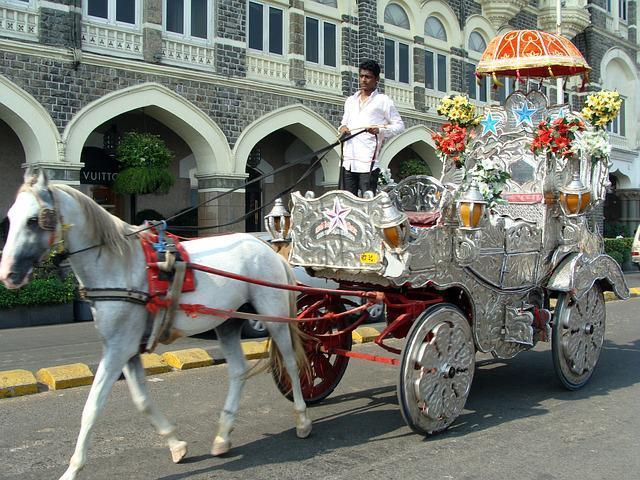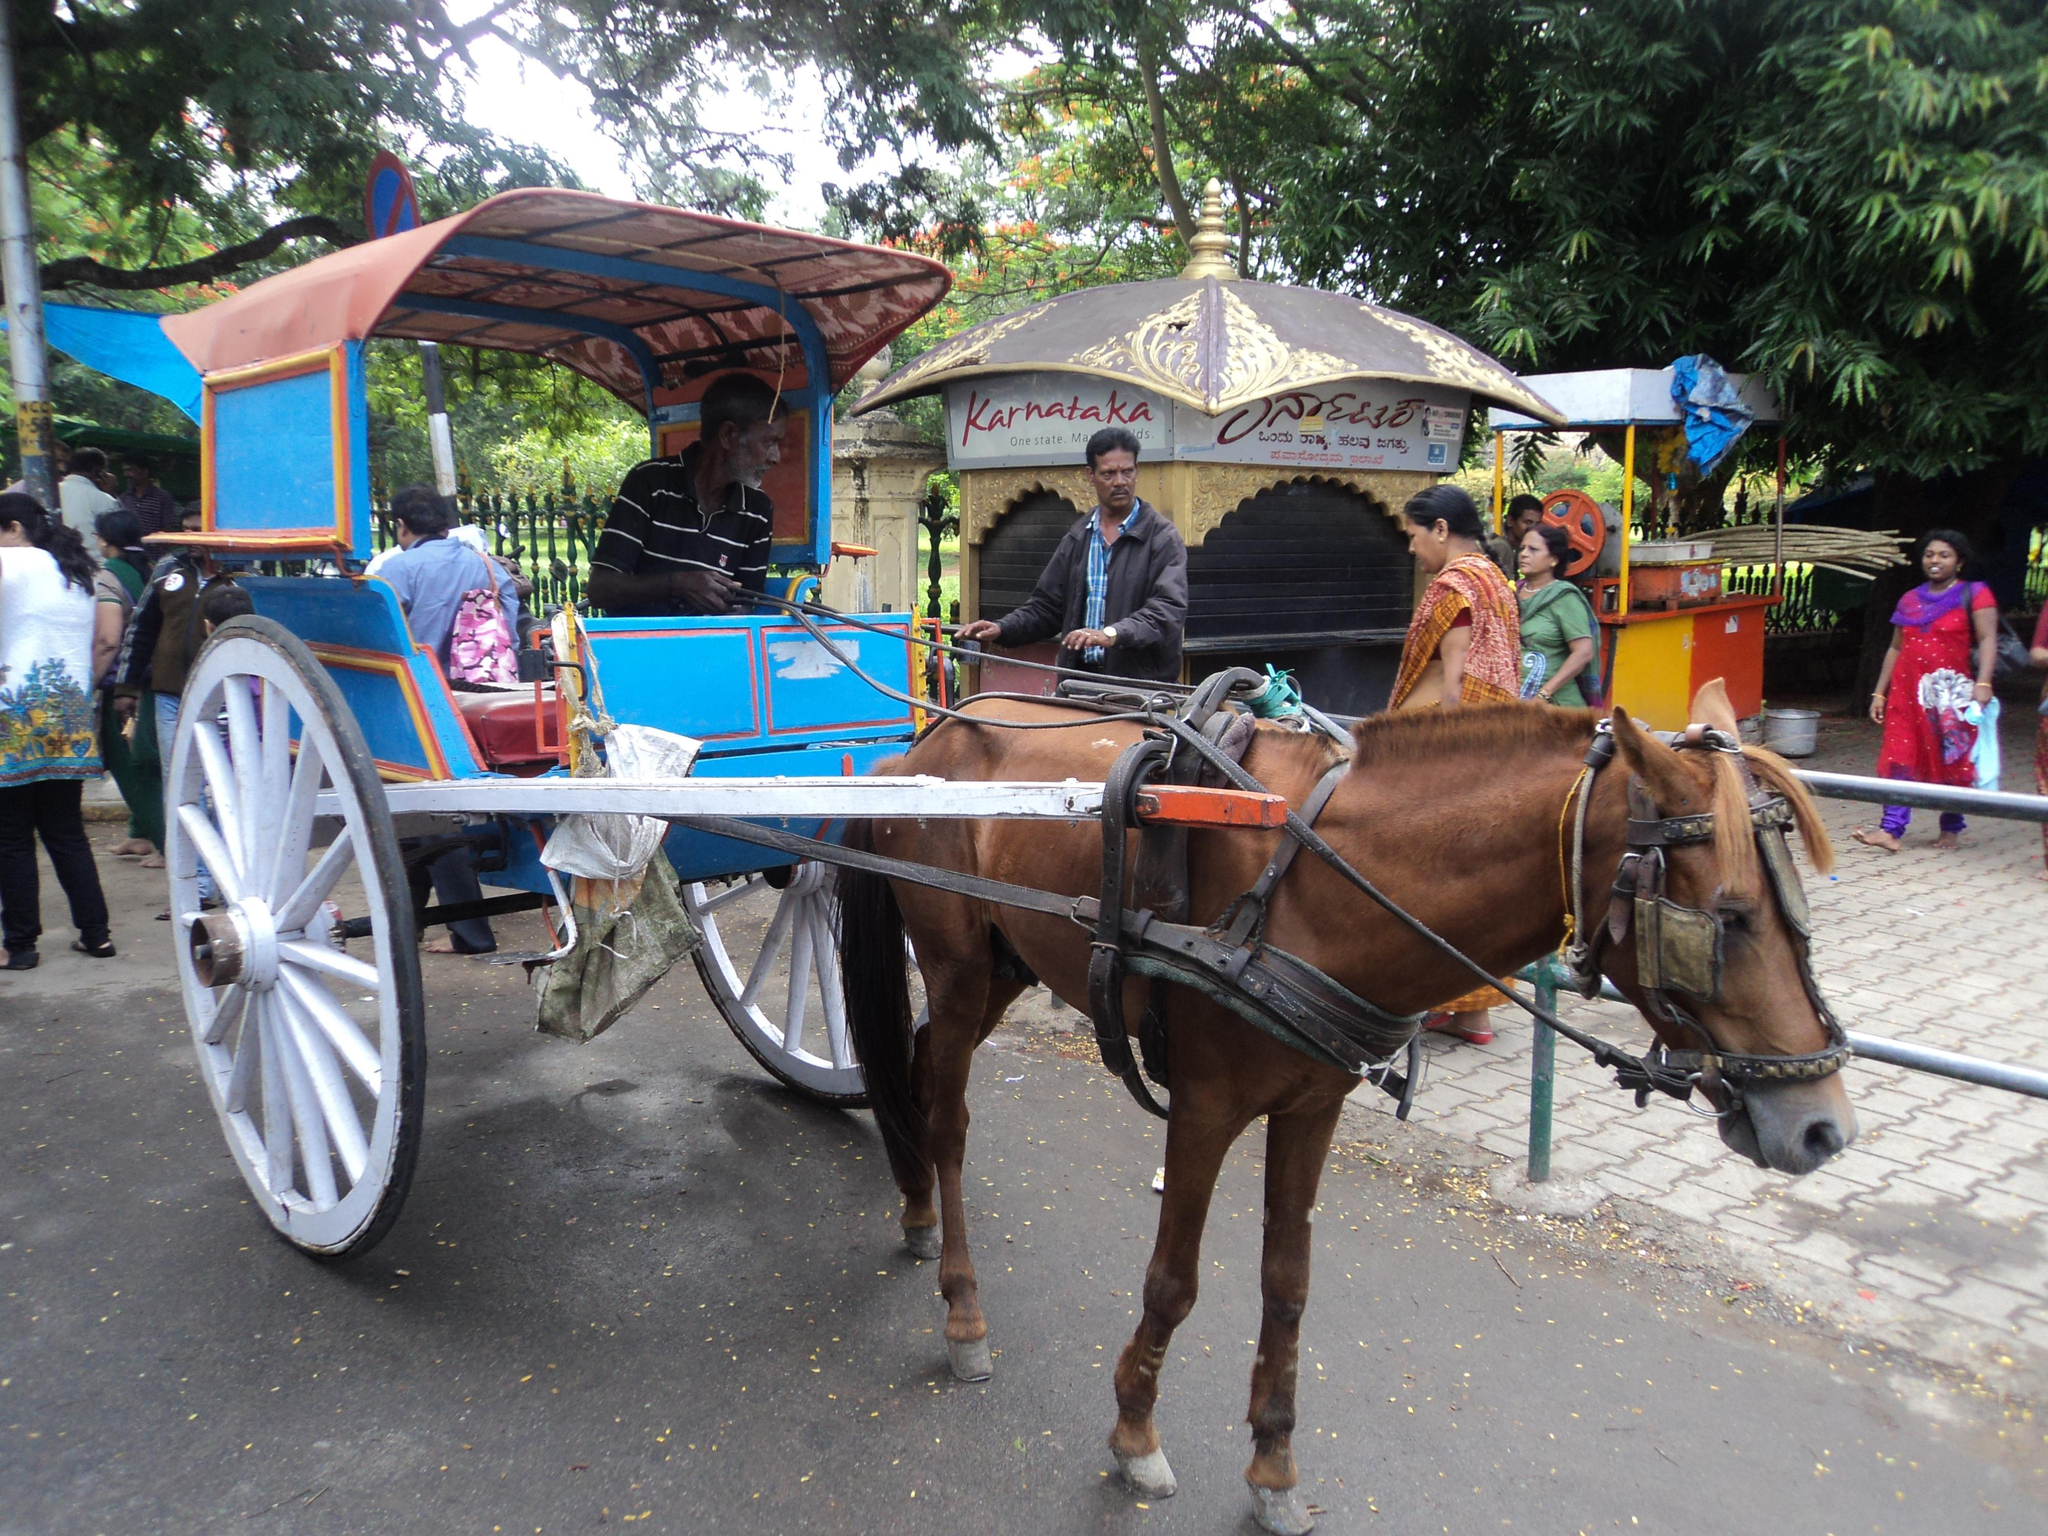The first image is the image on the left, the second image is the image on the right. Considering the images on both sides, is "The cart in one of the images is red." valid? Answer yes or no. No. 